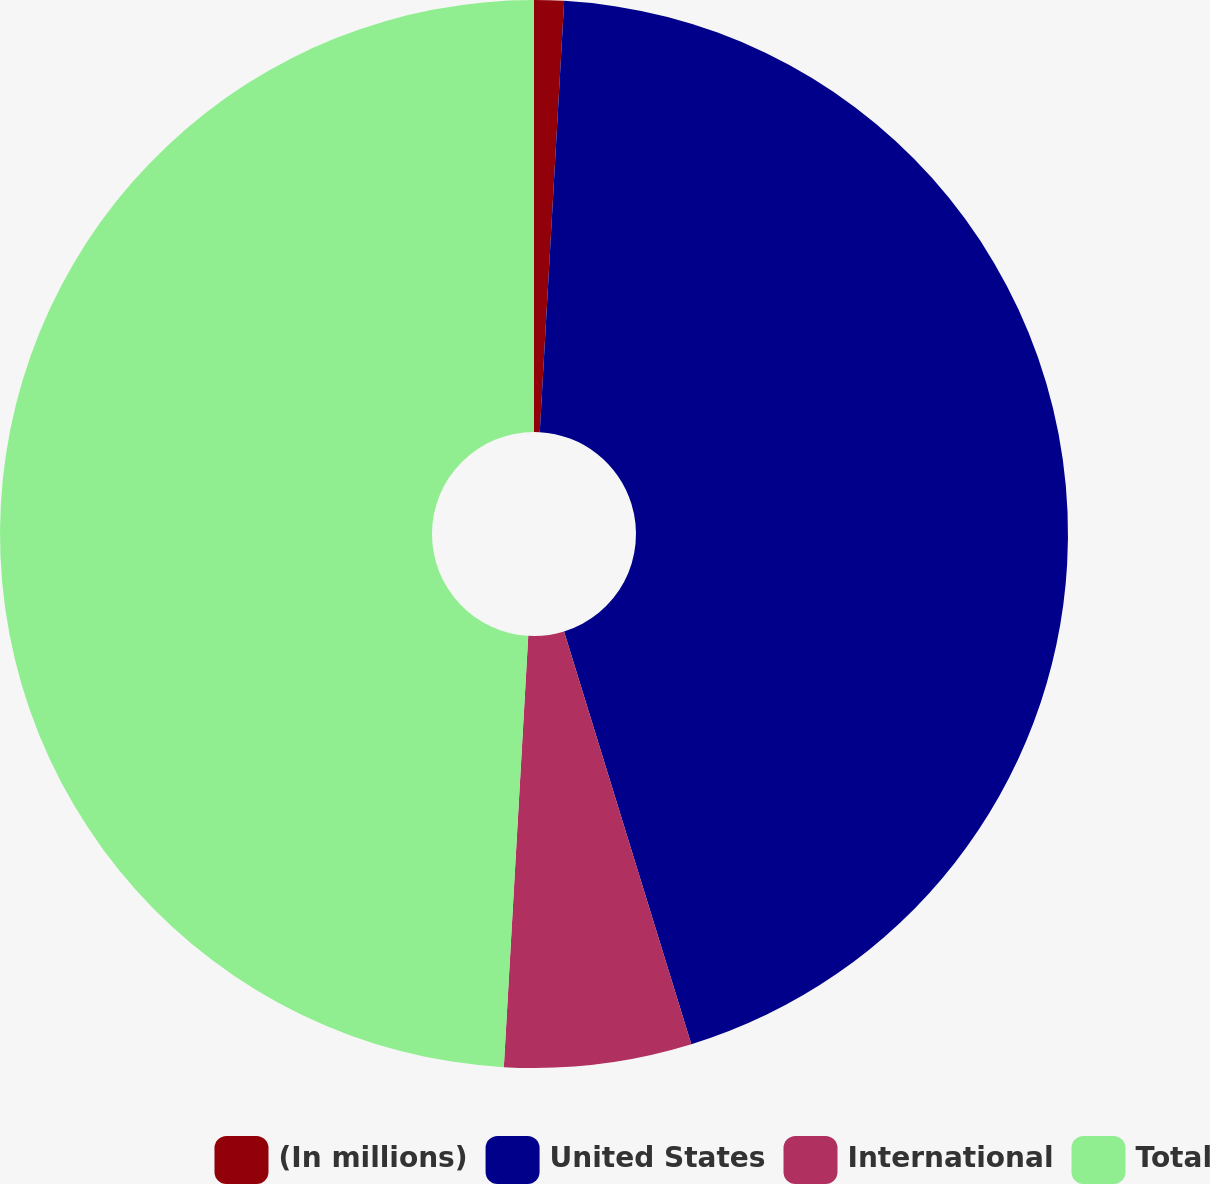<chart> <loc_0><loc_0><loc_500><loc_500><pie_chart><fcel>(In millions)<fcel>United States<fcel>International<fcel>Total<nl><fcel>0.9%<fcel>44.34%<fcel>5.66%<fcel>49.1%<nl></chart> 